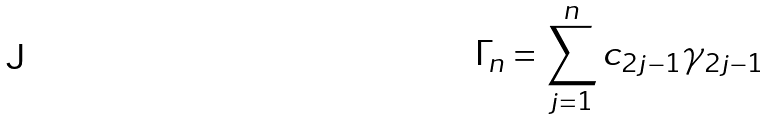<formula> <loc_0><loc_0><loc_500><loc_500>\Gamma _ { n } = \sum _ { j = 1 } ^ { n } c _ { 2 j - 1 } \gamma _ { 2 j - 1 }</formula> 